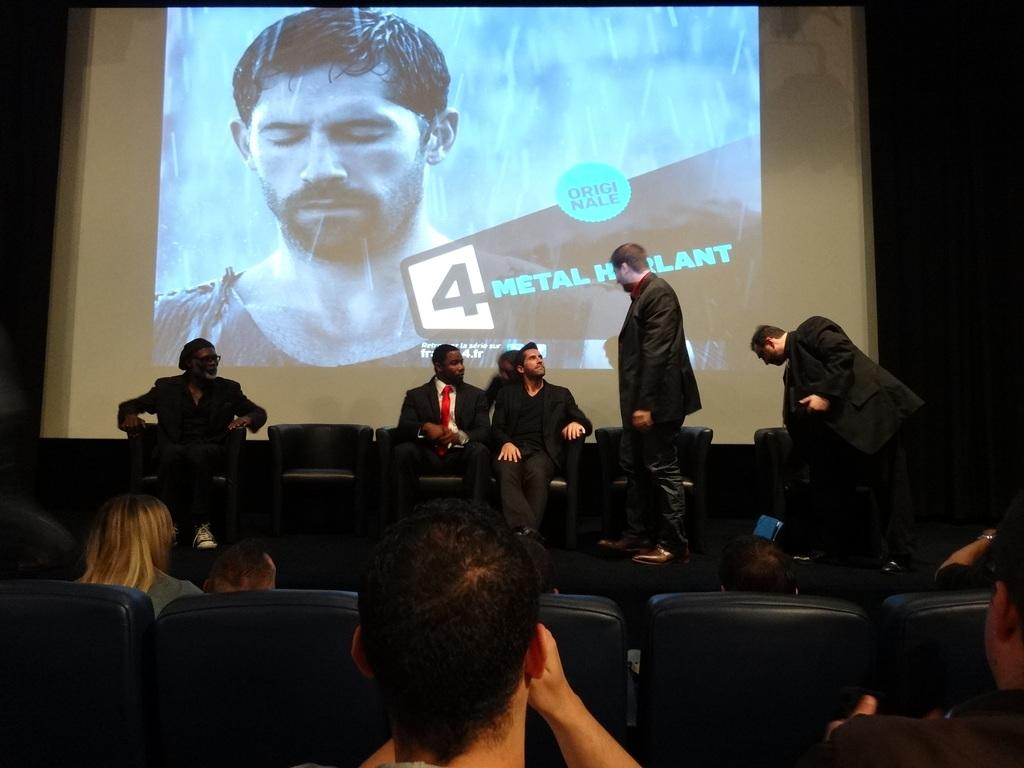What are the people in the image doing? There are people sitting on chairs and standing in the image. What can be seen in the background of the image? There is a huge screen in the background of the image. What is displayed on the screen? A person is visible on the screen. What is the condition of the screen? Water drops are present on the screen. What country is the person attempting to visit on the screen? There is no information about the person's travel plans or the country they are attempting to visit in the image. Additionally, the image does not show any attempt to visit a country. 